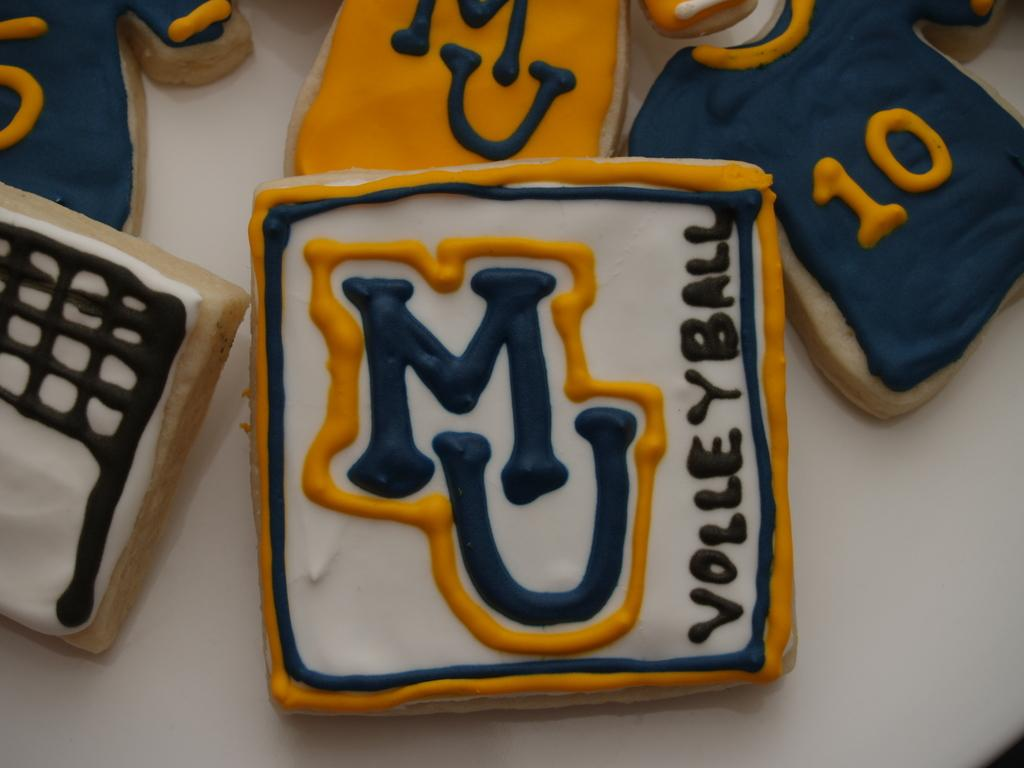<image>
Provide a brief description of the given image. white, blue, and orange cookies celebrating MU VOlleyball 